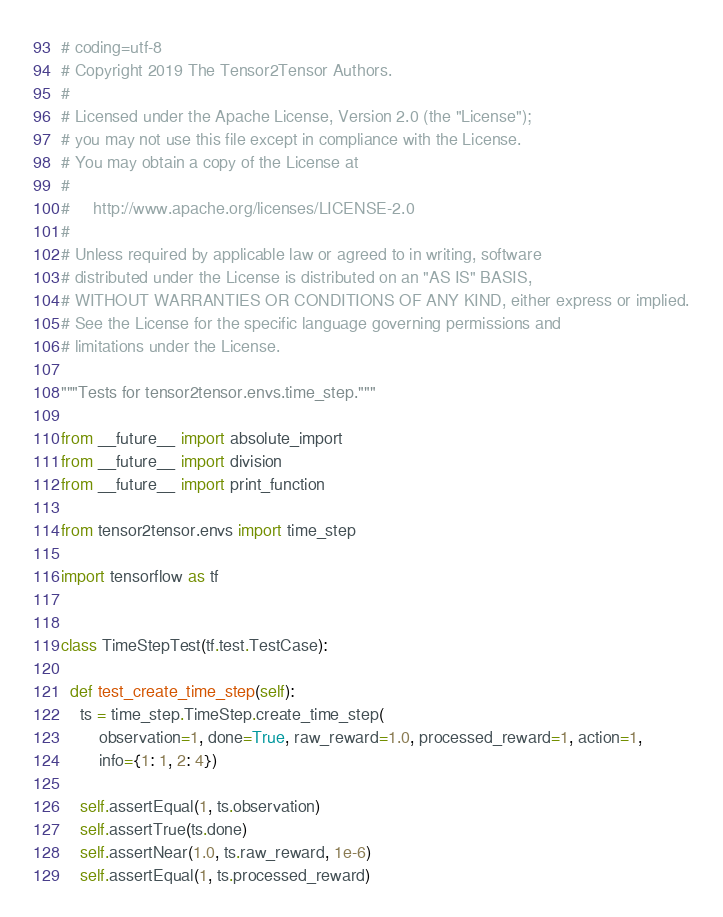<code> <loc_0><loc_0><loc_500><loc_500><_Python_># coding=utf-8
# Copyright 2019 The Tensor2Tensor Authors.
#
# Licensed under the Apache License, Version 2.0 (the "License");
# you may not use this file except in compliance with the License.
# You may obtain a copy of the License at
#
#     http://www.apache.org/licenses/LICENSE-2.0
#
# Unless required by applicable law or agreed to in writing, software
# distributed under the License is distributed on an "AS IS" BASIS,
# WITHOUT WARRANTIES OR CONDITIONS OF ANY KIND, either express or implied.
# See the License for the specific language governing permissions and
# limitations under the License.

"""Tests for tensor2tensor.envs.time_step."""

from __future__ import absolute_import
from __future__ import division
from __future__ import print_function

from tensor2tensor.envs import time_step

import tensorflow as tf


class TimeStepTest(tf.test.TestCase):

  def test_create_time_step(self):
    ts = time_step.TimeStep.create_time_step(
        observation=1, done=True, raw_reward=1.0, processed_reward=1, action=1,
        info={1: 1, 2: 4})

    self.assertEqual(1, ts.observation)
    self.assertTrue(ts.done)
    self.assertNear(1.0, ts.raw_reward, 1e-6)
    self.assertEqual(1, ts.processed_reward)</code> 